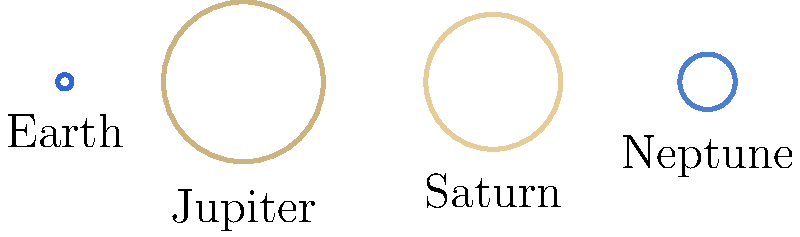As part of an educational initiative for immigrant communities, you're creating a presentation about the scale of our solar system. Using the diagram showing the relative sizes of Earth, Jupiter, Saturn, and Neptune, which planet is approximately 3.88 times larger than Earth in diameter? To determine which planet is approximately 3.88 times larger than Earth in diameter, let's analyze the information given in the diagram:

1. The diagram shows the relative sizes of Earth, Jupiter, Saturn, and Neptune.
2. Earth is used as the base unit for comparison.
3. The radii of the planets are given in relation to Earth's radius:
   - Jupiter: 11.2 times Earth's radius
   - Saturn: 9.45 times Earth's radius
   - Neptune: 3.88 times Earth's radius

4. The question asks about the diameter, which is twice the radius.
5. We're looking for a planet that is 3.88 times larger than Earth in diameter.
6. This directly corresponds to Neptune's radius in the diagram.

Therefore, Neptune is the planet that is approximately 3.88 times larger than Earth in diameter.

This comparison helps illustrate the vast differences in size between planets in our solar system, which can be an interesting point of discussion when explaining the scale of space to diverse communities.
Answer: Neptune 